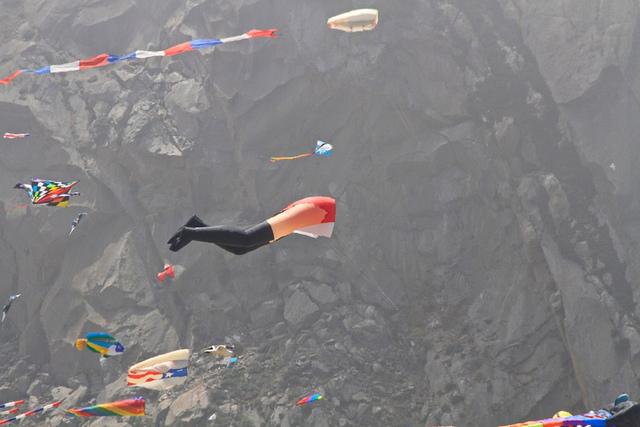Are the kites in flight?
Write a very short answer. Yes. What is wrong with the pair of legs?
Keep it brief. Kite. What point of view is the picture taken from?
Quick response, please. Kite. 